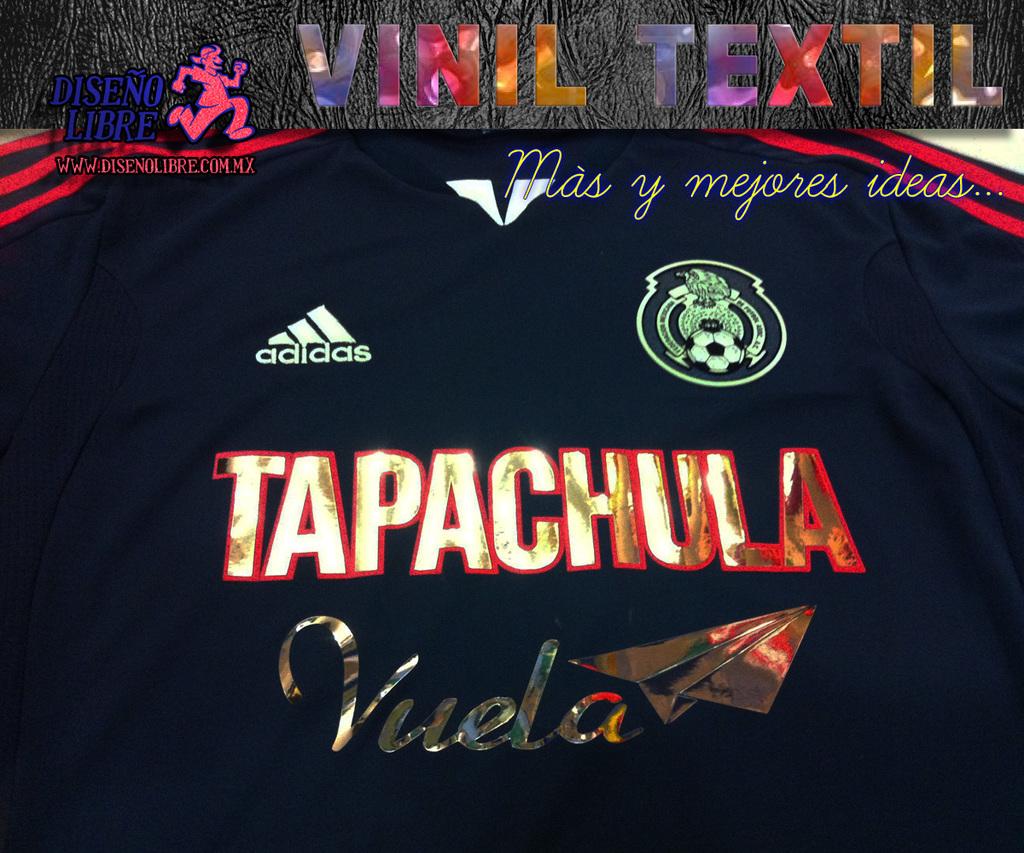Does the central text read tapachula?
Provide a succinct answer. Yes. 